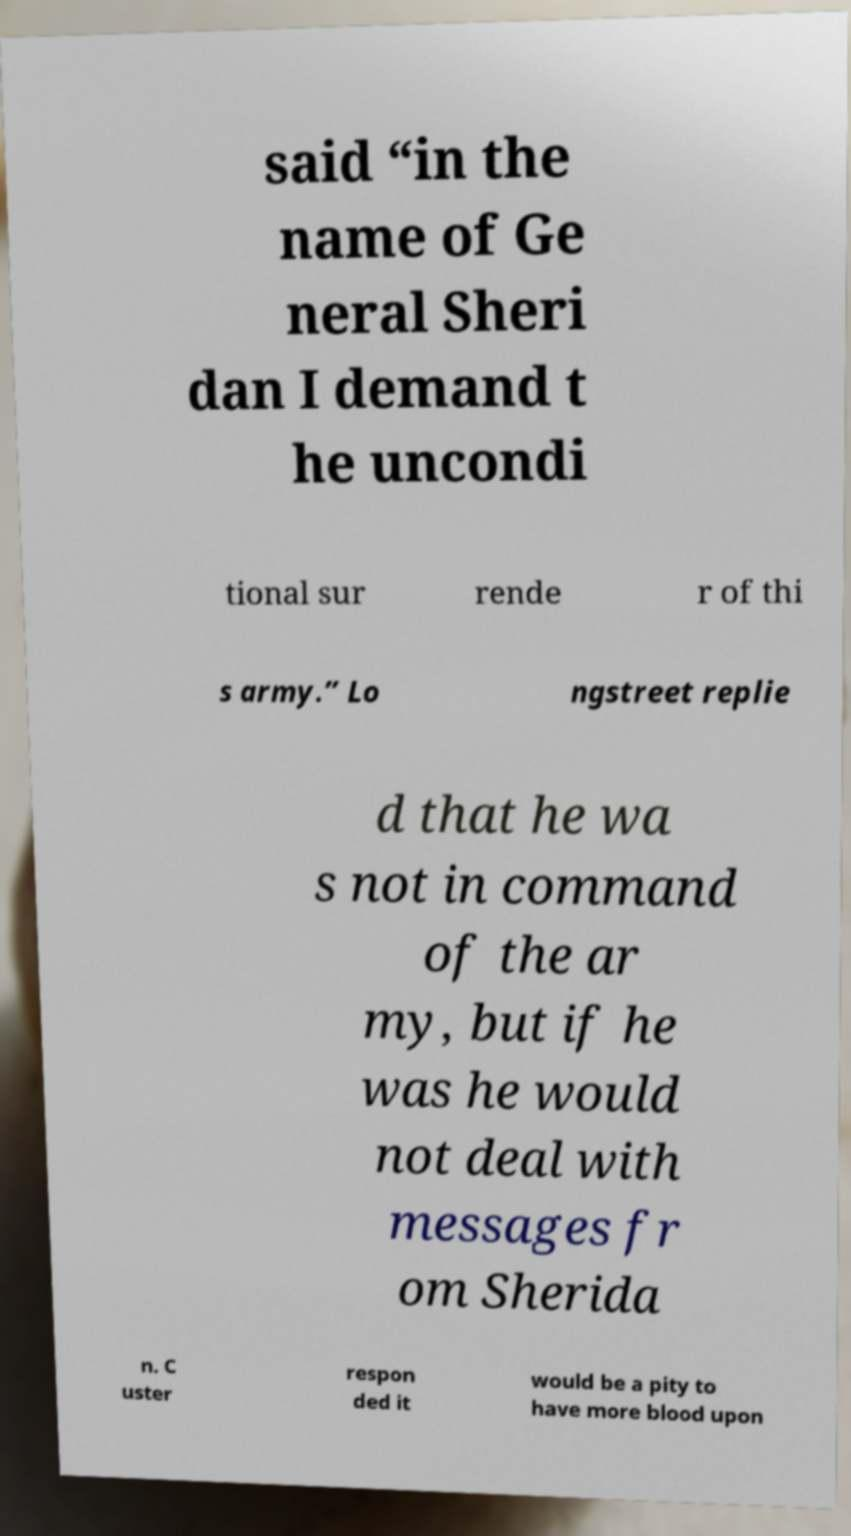Could you extract and type out the text from this image? said “in the name of Ge neral Sheri dan I demand t he uncondi tional sur rende r of thi s army.” Lo ngstreet replie d that he wa s not in command of the ar my, but if he was he would not deal with messages fr om Sherida n. C uster respon ded it would be a pity to have more blood upon 